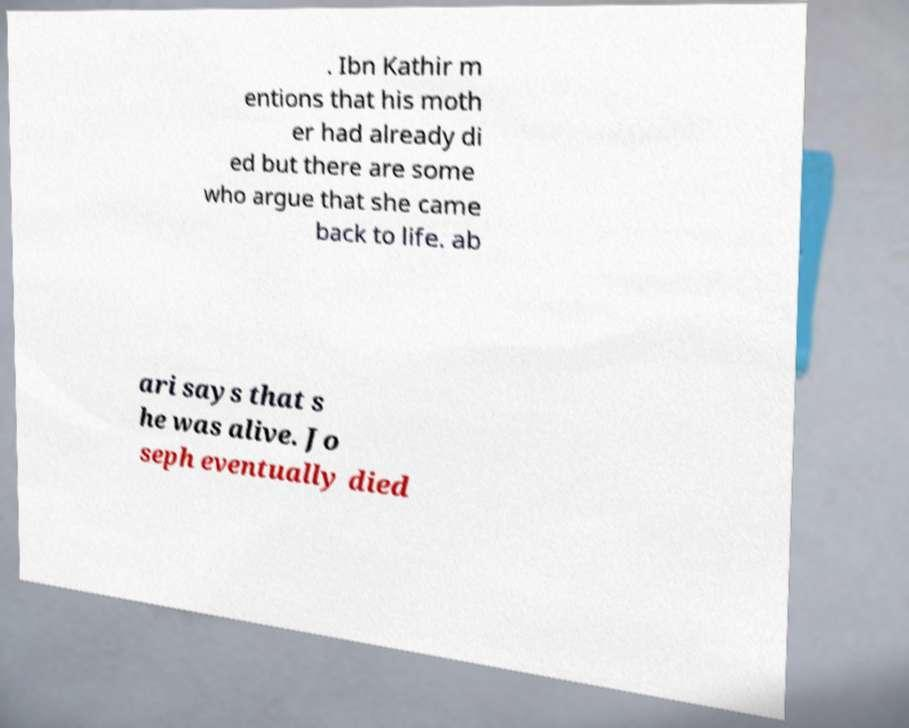Please read and relay the text visible in this image. What does it say? . Ibn Kathir m entions that his moth er had already di ed but there are some who argue that she came back to life. ab ari says that s he was alive. Jo seph eventually died 